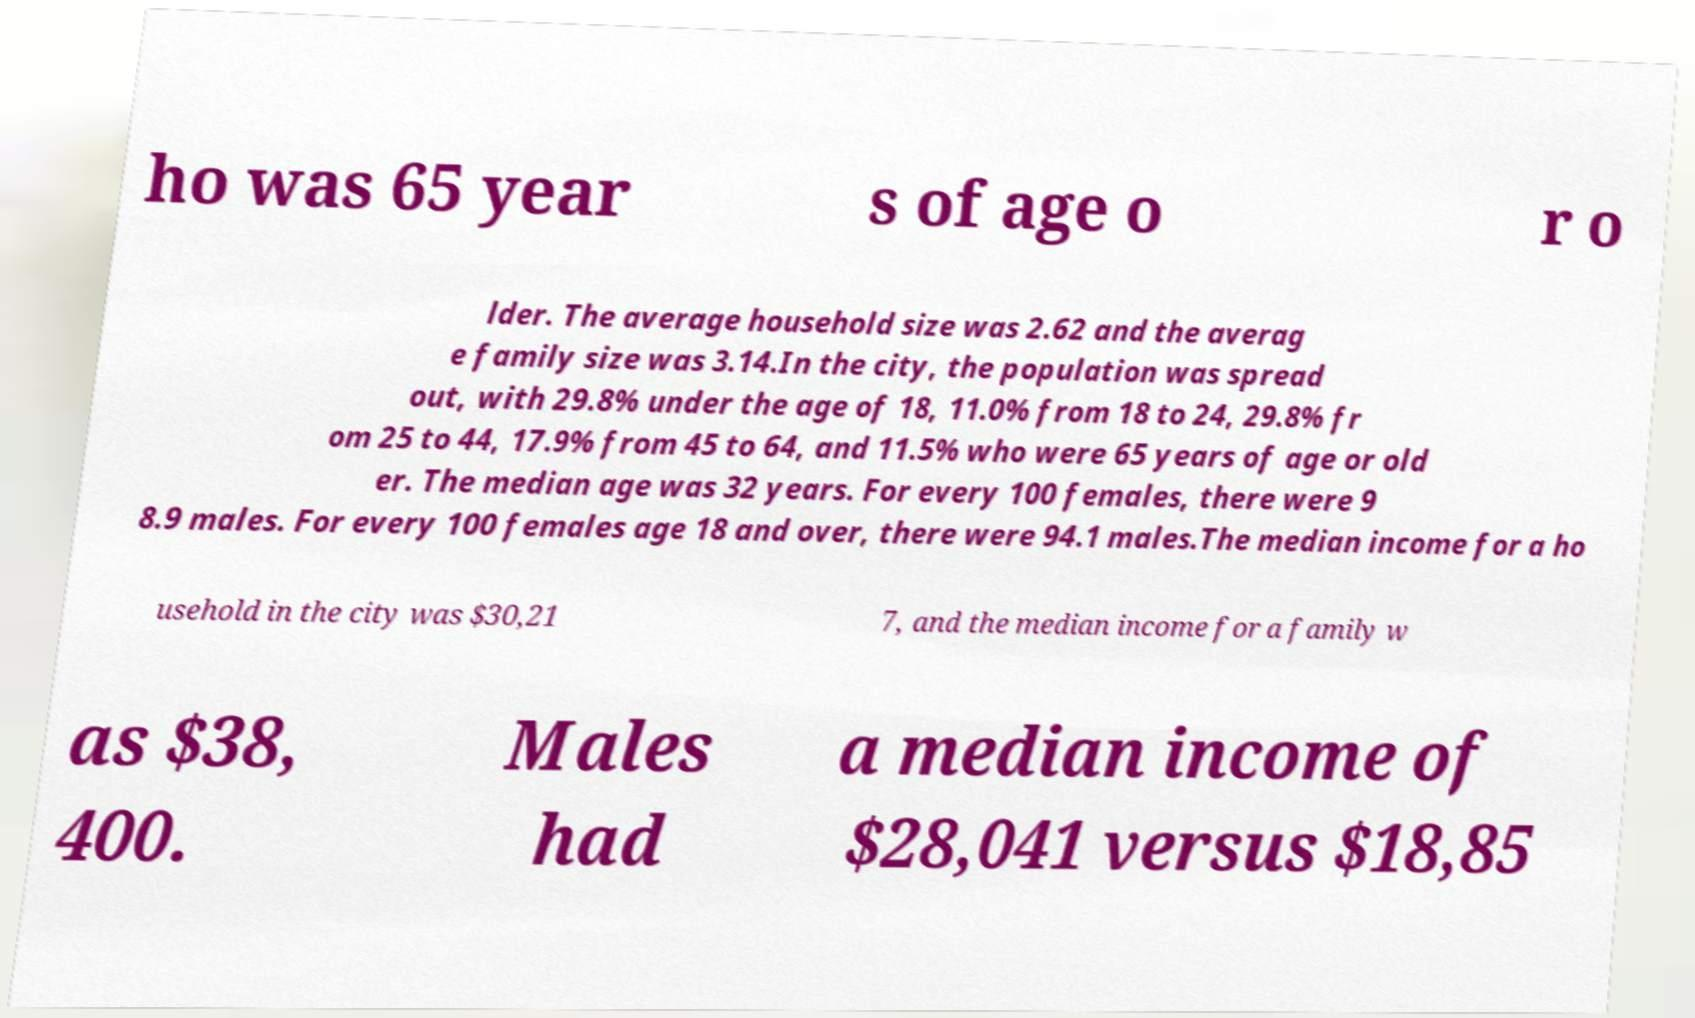Please identify and transcribe the text found in this image. ho was 65 year s of age o r o lder. The average household size was 2.62 and the averag e family size was 3.14.In the city, the population was spread out, with 29.8% under the age of 18, 11.0% from 18 to 24, 29.8% fr om 25 to 44, 17.9% from 45 to 64, and 11.5% who were 65 years of age or old er. The median age was 32 years. For every 100 females, there were 9 8.9 males. For every 100 females age 18 and over, there were 94.1 males.The median income for a ho usehold in the city was $30,21 7, and the median income for a family w as $38, 400. Males had a median income of $28,041 versus $18,85 